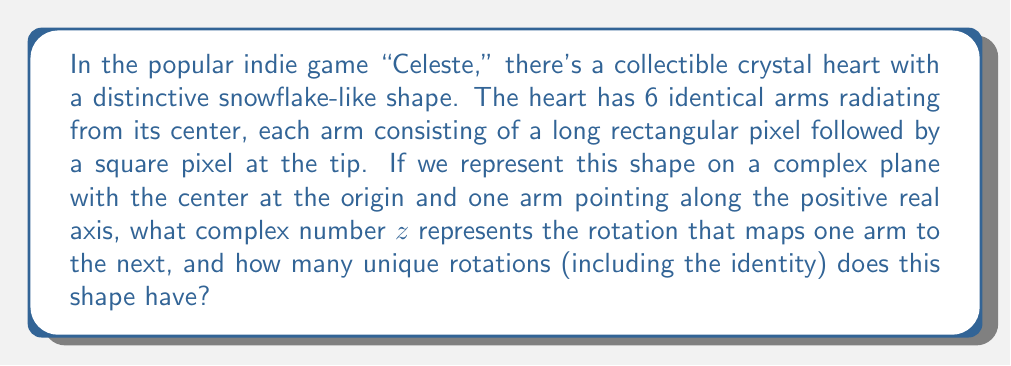Help me with this question. Let's approach this step-by-step:

1) First, we need to understand rotational symmetry. A shape has rotational symmetry if it can be rotated about its center by a certain angle and still look the same.

2) In this case, we have 6 identical arms. This means we can rotate the shape by $\frac{360°}{6} = 60°$ and it will look the same.

3) In complex number theory, rotations are represented by multiplying by a complex number of the form $e^{i\theta}$, where $\theta$ is the angle of rotation in radians.

4) To convert 60° to radians, we use the formula:
   $$\theta = 60° \cdot \frac{\pi}{180°} = \frac{\pi}{3}$$

5) Therefore, the complex number $z$ that represents this rotation is:
   $$z = e^{i\frac{\pi}{3}}$$

6) We can also express this in rectangular form:
   $$z = \cos(\frac{\pi}{3}) + i\sin(\frac{\pi}{3}) = \frac{1}{2} + i\frac{\sqrt{3}}{2}$$

7) To find the number of unique rotations, we need to keep applying this rotation until we get back to our starting position. Each application gives us:
   - $z^1 = e^{i\frac{\pi}{3}}$ (60° rotation)
   - $z^2 = e^{i\frac{2\pi}{3}}$ (120° rotation)
   - $z^3 = e^{i\pi} = -1$ (180° rotation)
   - $z^4 = e^{i\frac{4\pi}{3}}$ (240° rotation)
   - $z^5 = e^{i\frac{5\pi}{3}}$ (300° rotation)
   - $z^6 = e^{i2\pi} = 1$ (360° rotation, back to start)

8) Including the identity rotation (no rotation, or 0°), we have 6 unique rotations.
Answer: The complex number representing the rotation from one arm to the next is $z = e^{i\frac{\pi}{3}} = \frac{1}{2} + i\frac{\sqrt{3}}{2}$, and the shape has 6 unique rotations (including the identity rotation). 